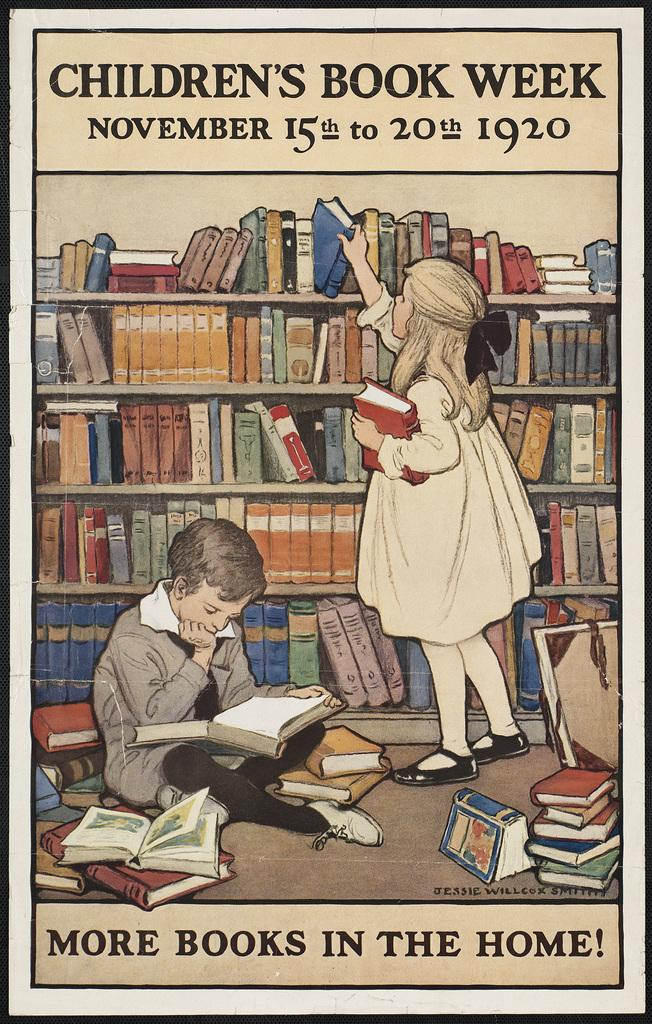Provide a one-sentence caption for the provided image. A poster for Children's Book Week showing two children surrounded by books. 